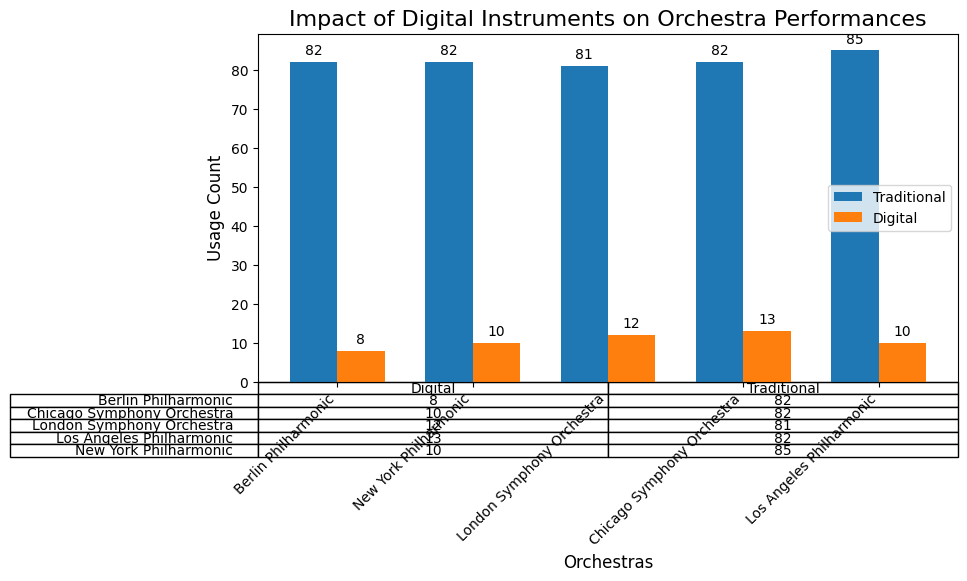What is the total usage count of digital instruments for the Berlin Philharmonic? From the table, sum the usage counts of the digital instruments (Synthesizer and Electric Guitar) for the Berlin Philharmonic: 5 (Synthesizer) + 3 (Electric Guitar) = 8
Answer: 8 Which orchestra uses the most synthesizers? Compare the usage count of synthesizers among all orchestras in the table: Berlin Philharmonic (5), New York Philharmonic (6), London Symphony Orchestra (7), Chicago Symphony Orchestra (6), Los Angeles Philharmonic (8). The Los Angeles Philharmonic has the highest usage count of synthesizers, which is 8.
Answer: Los Angeles Philharmonic What is the difference in the total usage count of traditional instruments between the New York Philharmonic and the Chicago Symphony Orchestra? From the table, sum the usage counts of traditional instruments for both orchestras and calculate the difference: New York Philharmonic (58 + 12 + 15 = 85), Chicago Symphony Orchestra (60 + 10 + 12 = 82). The difference is 85 - 82 = 3
Answer: 3 How many instruments in total are used by the London Symphony Orchestra? Sum the usage counts of all instruments (both traditional and digital) for the London Symphony Orchestra from the table: 55 + 12 + 7 + 14 + 5 = 93
Answer: 93 Which orchestra has the least total usage count of digital instruments? Compare the total usage counts of digital instruments for all orchestras in the table: Berlin Philharmonic (5+3=8), New York Philharmonic (6+4=10), London Symphony Orchestra (7+5=12), Chicago Symphony Orchestra (6+4=10), Los Angeles Philharmonic (8+5=13). The Berlin Philharmonic has the lowest total usage count of digital instruments, which is 8.
Answer: Berlin Philharmonic What is the average number of traditional instruments used across all orchestras? Calculate the average by summing up the total usage count of traditional instruments for all orchestras and then dividing by the number of orchestras. (60+10+12 + 58+12+15 + 55+12+14 + 60+10+12 + 57+11+14 = 372). There are 5 orchestras, so the average is 372/5 = 74.4
Answer: 74.4 How does the usage count of electric guitars in the London Symphony Orchestra compare to that in the Chicago Symphony Orchestra? From the table, compare the usage counts of electric guitars in both orchestras: London Symphony Orchestra (5), Chicago Symphony Orchestra (4). The London Symphony Orchestra uses 1 more electric guitar compared to the Chicago Symphony Orchestra.
Answer: London Symphony Orchestra uses 1 more Which type of instrument has a higher usage count in the Los Angeles Philharmonic, traditional or digital? From the table, sum the usage counts of traditional and digital instruments for the Los Angeles Philharmonic: Traditional (57 + 11 + 14 = 82), Digital (8 + 5 = 13). Traditional instruments have a significantly higher usage count.
Answer: Traditional What is the total usage count for pianos across all orchestras? Sum the usage counts of pianos from each orchestra in the table: 10 (Berlin Philharmonic) + 12 (New York Philharmonic) + 12 (London Symphony Orchestra) + 10 (Chicago Symphony Orchestra) + 11 (Los Angeles Philharmonic) = 55
Answer: 55 What is the percentage of synthesizers compared to the total digital instruments in the New York Philharmonic? Find the total count of digital instruments and the count of synthesizers in the New York Philharmonic: Digital (6 + 4 = 10), Synthesizer = 6. The percentage is (6/10) * 100 = 60%
Answer: 60% 